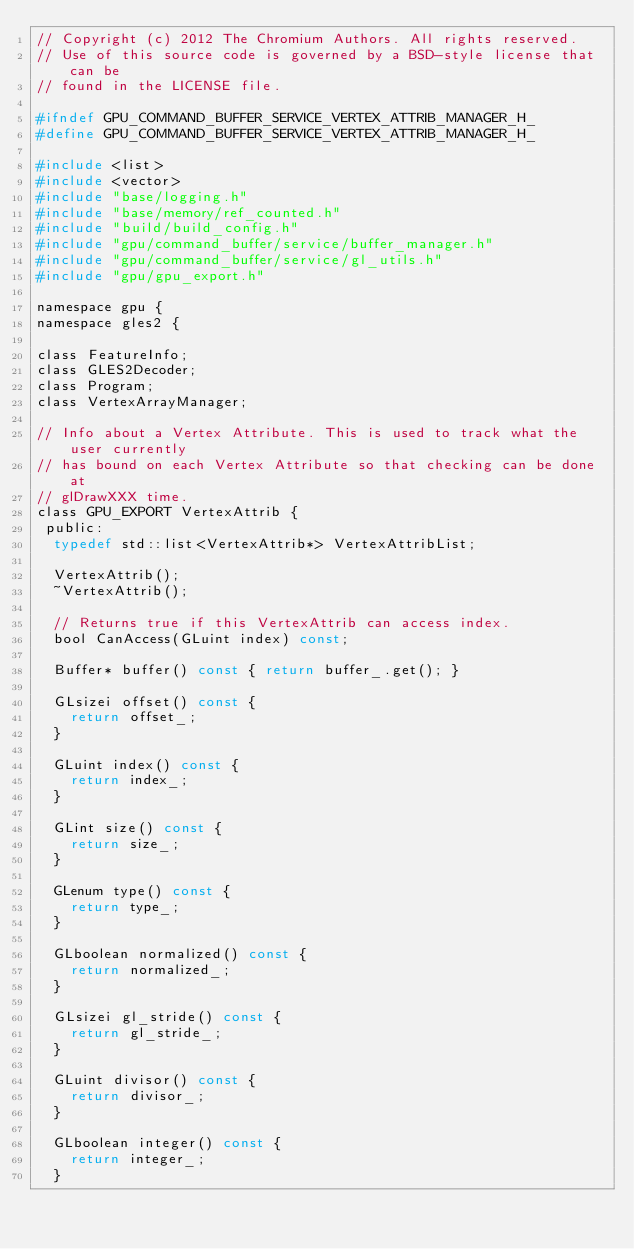<code> <loc_0><loc_0><loc_500><loc_500><_C_>// Copyright (c) 2012 The Chromium Authors. All rights reserved.
// Use of this source code is governed by a BSD-style license that can be
// found in the LICENSE file.

#ifndef GPU_COMMAND_BUFFER_SERVICE_VERTEX_ATTRIB_MANAGER_H_
#define GPU_COMMAND_BUFFER_SERVICE_VERTEX_ATTRIB_MANAGER_H_

#include <list>
#include <vector>
#include "base/logging.h"
#include "base/memory/ref_counted.h"
#include "build/build_config.h"
#include "gpu/command_buffer/service/buffer_manager.h"
#include "gpu/command_buffer/service/gl_utils.h"
#include "gpu/gpu_export.h"

namespace gpu {
namespace gles2 {

class FeatureInfo;
class GLES2Decoder;
class Program;
class VertexArrayManager;

// Info about a Vertex Attribute. This is used to track what the user currently
// has bound on each Vertex Attribute so that checking can be done at
// glDrawXXX time.
class GPU_EXPORT VertexAttrib {
 public:
  typedef std::list<VertexAttrib*> VertexAttribList;

  VertexAttrib();
  ~VertexAttrib();

  // Returns true if this VertexAttrib can access index.
  bool CanAccess(GLuint index) const;

  Buffer* buffer() const { return buffer_.get(); }

  GLsizei offset() const {
    return offset_;
  }

  GLuint index() const {
    return index_;
  }

  GLint size() const {
    return size_;
  }

  GLenum type() const {
    return type_;
  }

  GLboolean normalized() const {
    return normalized_;
  }

  GLsizei gl_stride() const {
    return gl_stride_;
  }

  GLuint divisor() const {
    return divisor_;
  }

  GLboolean integer() const {
    return integer_;
  }
</code> 